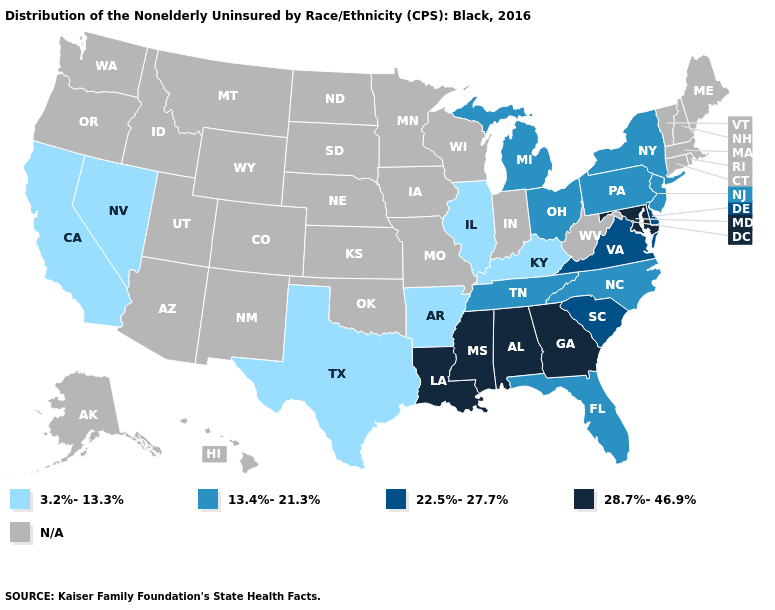What is the lowest value in states that border Arizona?
Quick response, please. 3.2%-13.3%. What is the value of Tennessee?
Give a very brief answer. 13.4%-21.3%. What is the value of Connecticut?
Concise answer only. N/A. Name the states that have a value in the range 3.2%-13.3%?
Be succinct. Arkansas, California, Illinois, Kentucky, Nevada, Texas. Does Kentucky have the lowest value in the South?
Give a very brief answer. Yes. Does the first symbol in the legend represent the smallest category?
Keep it brief. Yes. What is the highest value in the USA?
Concise answer only. 28.7%-46.9%. Does the first symbol in the legend represent the smallest category?
Concise answer only. Yes. Is the legend a continuous bar?
Give a very brief answer. No. What is the value of Idaho?
Short answer required. N/A. Does the map have missing data?
Be succinct. Yes. What is the lowest value in the USA?
Be succinct. 3.2%-13.3%. Does the first symbol in the legend represent the smallest category?
Be succinct. Yes. Among the states that border Pennsylvania , does Maryland have the highest value?
Give a very brief answer. Yes. 